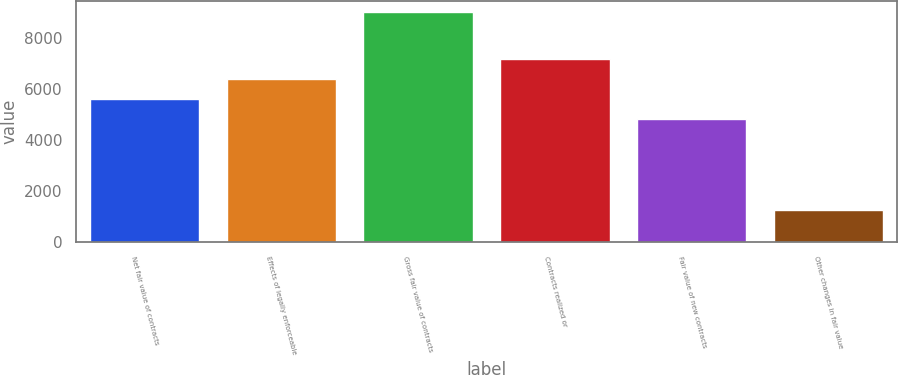Convert chart. <chart><loc_0><loc_0><loc_500><loc_500><bar_chart><fcel>Net fair value of contracts<fcel>Effects of legally enforceable<fcel>Gross fair value of contracts<fcel>Contracts realized or<fcel>Fair value of new contracts<fcel>Other changes in fair value<nl><fcel>5617.6<fcel>6405.9<fcel>9001<fcel>7194.2<fcel>4829.3<fcel>1268<nl></chart> 